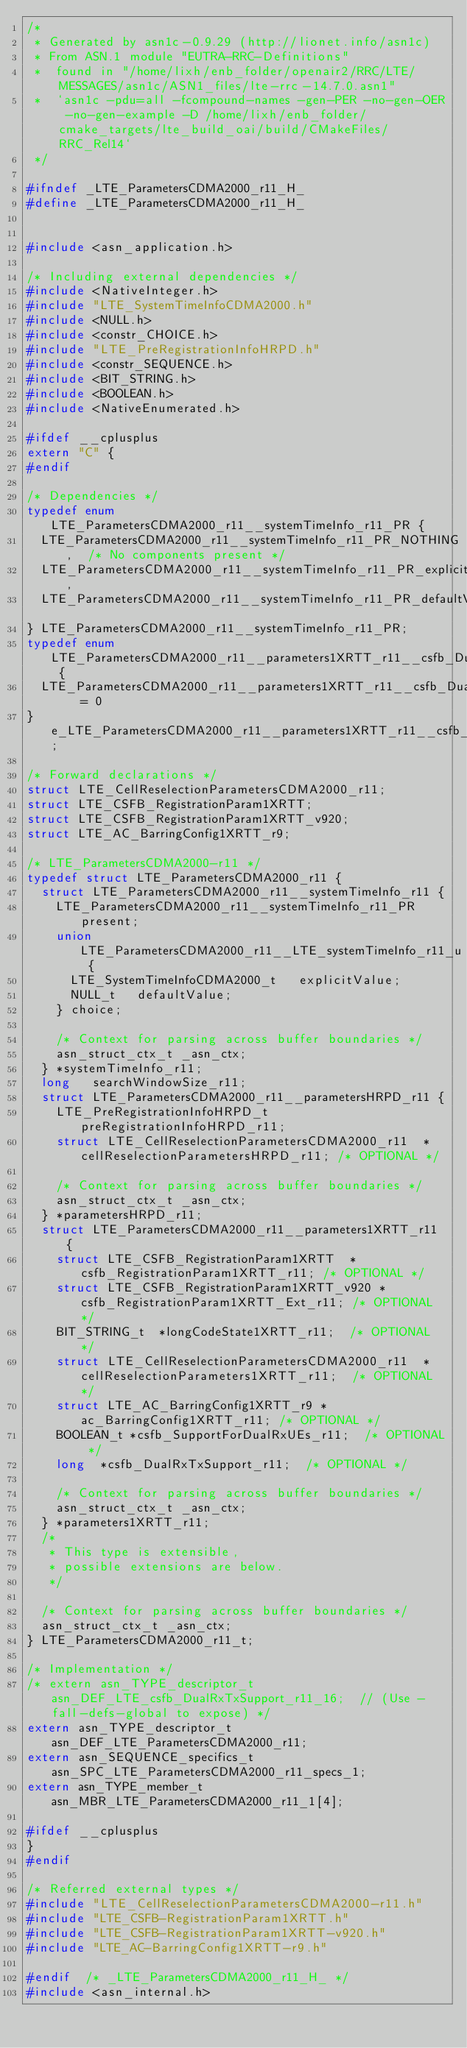Convert code to text. <code><loc_0><loc_0><loc_500><loc_500><_C_>/*
 * Generated by asn1c-0.9.29 (http://lionet.info/asn1c)
 * From ASN.1 module "EUTRA-RRC-Definitions"
 * 	found in "/home/lixh/enb_folder/openair2/RRC/LTE/MESSAGES/asn1c/ASN1_files/lte-rrc-14.7.0.asn1"
 * 	`asn1c -pdu=all -fcompound-names -gen-PER -no-gen-OER -no-gen-example -D /home/lixh/enb_folder/cmake_targets/lte_build_oai/build/CMakeFiles/RRC_Rel14`
 */

#ifndef	_LTE_ParametersCDMA2000_r11_H_
#define	_LTE_ParametersCDMA2000_r11_H_


#include <asn_application.h>

/* Including external dependencies */
#include <NativeInteger.h>
#include "LTE_SystemTimeInfoCDMA2000.h"
#include <NULL.h>
#include <constr_CHOICE.h>
#include "LTE_PreRegistrationInfoHRPD.h"
#include <constr_SEQUENCE.h>
#include <BIT_STRING.h>
#include <BOOLEAN.h>
#include <NativeEnumerated.h>

#ifdef __cplusplus
extern "C" {
#endif

/* Dependencies */
typedef enum LTE_ParametersCDMA2000_r11__systemTimeInfo_r11_PR {
	LTE_ParametersCDMA2000_r11__systemTimeInfo_r11_PR_NOTHING,	/* No components present */
	LTE_ParametersCDMA2000_r11__systemTimeInfo_r11_PR_explicitValue,
	LTE_ParametersCDMA2000_r11__systemTimeInfo_r11_PR_defaultValue
} LTE_ParametersCDMA2000_r11__systemTimeInfo_r11_PR;
typedef enum LTE_ParametersCDMA2000_r11__parameters1XRTT_r11__csfb_DualRxTxSupport_r11 {
	LTE_ParametersCDMA2000_r11__parameters1XRTT_r11__csfb_DualRxTxSupport_r11_true	= 0
} e_LTE_ParametersCDMA2000_r11__parameters1XRTT_r11__csfb_DualRxTxSupport_r11;

/* Forward declarations */
struct LTE_CellReselectionParametersCDMA2000_r11;
struct LTE_CSFB_RegistrationParam1XRTT;
struct LTE_CSFB_RegistrationParam1XRTT_v920;
struct LTE_AC_BarringConfig1XRTT_r9;

/* LTE_ParametersCDMA2000-r11 */
typedef struct LTE_ParametersCDMA2000_r11 {
	struct LTE_ParametersCDMA2000_r11__systemTimeInfo_r11 {
		LTE_ParametersCDMA2000_r11__systemTimeInfo_r11_PR present;
		union LTE_ParametersCDMA2000_r11__LTE_systemTimeInfo_r11_u {
			LTE_SystemTimeInfoCDMA2000_t	 explicitValue;
			NULL_t	 defaultValue;
		} choice;
		
		/* Context for parsing across buffer boundaries */
		asn_struct_ctx_t _asn_ctx;
	} *systemTimeInfo_r11;
	long	 searchWindowSize_r11;
	struct LTE_ParametersCDMA2000_r11__parametersHRPD_r11 {
		LTE_PreRegistrationInfoHRPD_t	 preRegistrationInfoHRPD_r11;
		struct LTE_CellReselectionParametersCDMA2000_r11	*cellReselectionParametersHRPD_r11;	/* OPTIONAL */
		
		/* Context for parsing across buffer boundaries */
		asn_struct_ctx_t _asn_ctx;
	} *parametersHRPD_r11;
	struct LTE_ParametersCDMA2000_r11__parameters1XRTT_r11 {
		struct LTE_CSFB_RegistrationParam1XRTT	*csfb_RegistrationParam1XRTT_r11;	/* OPTIONAL */
		struct LTE_CSFB_RegistrationParam1XRTT_v920	*csfb_RegistrationParam1XRTT_Ext_r11;	/* OPTIONAL */
		BIT_STRING_t	*longCodeState1XRTT_r11;	/* OPTIONAL */
		struct LTE_CellReselectionParametersCDMA2000_r11	*cellReselectionParameters1XRTT_r11;	/* OPTIONAL */
		struct LTE_AC_BarringConfig1XRTT_r9	*ac_BarringConfig1XRTT_r11;	/* OPTIONAL */
		BOOLEAN_t	*csfb_SupportForDualRxUEs_r11;	/* OPTIONAL */
		long	*csfb_DualRxTxSupport_r11;	/* OPTIONAL */
		
		/* Context for parsing across buffer boundaries */
		asn_struct_ctx_t _asn_ctx;
	} *parameters1XRTT_r11;
	/*
	 * This type is extensible,
	 * possible extensions are below.
	 */
	
	/* Context for parsing across buffer boundaries */
	asn_struct_ctx_t _asn_ctx;
} LTE_ParametersCDMA2000_r11_t;

/* Implementation */
/* extern asn_TYPE_descriptor_t asn_DEF_LTE_csfb_DualRxTxSupport_r11_16;	// (Use -fall-defs-global to expose) */
extern asn_TYPE_descriptor_t asn_DEF_LTE_ParametersCDMA2000_r11;
extern asn_SEQUENCE_specifics_t asn_SPC_LTE_ParametersCDMA2000_r11_specs_1;
extern asn_TYPE_member_t asn_MBR_LTE_ParametersCDMA2000_r11_1[4];

#ifdef __cplusplus
}
#endif

/* Referred external types */
#include "LTE_CellReselectionParametersCDMA2000-r11.h"
#include "LTE_CSFB-RegistrationParam1XRTT.h"
#include "LTE_CSFB-RegistrationParam1XRTT-v920.h"
#include "LTE_AC-BarringConfig1XRTT-r9.h"

#endif	/* _LTE_ParametersCDMA2000_r11_H_ */
#include <asn_internal.h>
</code> 